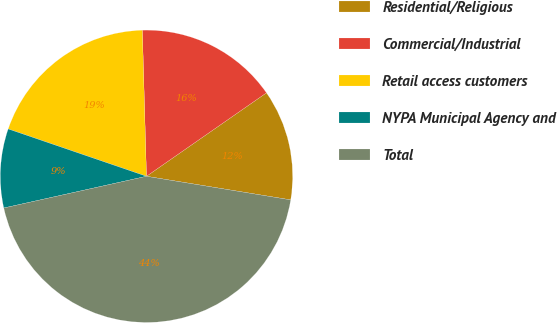Convert chart. <chart><loc_0><loc_0><loc_500><loc_500><pie_chart><fcel>Residential/Religious<fcel>Commercial/Industrial<fcel>Retail access customers<fcel>NYPA Municipal Agency and<fcel>Total<nl><fcel>12.25%<fcel>15.78%<fcel>19.3%<fcel>8.73%<fcel>43.94%<nl></chart> 